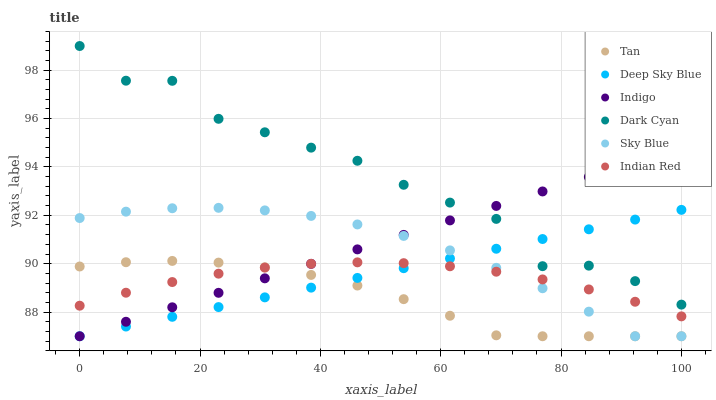Does Tan have the minimum area under the curve?
Answer yes or no. Yes. Does Dark Cyan have the maximum area under the curve?
Answer yes or no. Yes. Does Deep Sky Blue have the minimum area under the curve?
Answer yes or no. No. Does Deep Sky Blue have the maximum area under the curve?
Answer yes or no. No. Is Deep Sky Blue the smoothest?
Answer yes or no. Yes. Is Dark Cyan the roughest?
Answer yes or no. Yes. Is Indian Red the smoothest?
Answer yes or no. No. Is Indian Red the roughest?
Answer yes or no. No. Does Indigo have the lowest value?
Answer yes or no. Yes. Does Indian Red have the lowest value?
Answer yes or no. No. Does Dark Cyan have the highest value?
Answer yes or no. Yes. Does Deep Sky Blue have the highest value?
Answer yes or no. No. Is Sky Blue less than Dark Cyan?
Answer yes or no. Yes. Is Dark Cyan greater than Indian Red?
Answer yes or no. Yes. Does Indian Red intersect Indigo?
Answer yes or no. Yes. Is Indian Red less than Indigo?
Answer yes or no. No. Is Indian Red greater than Indigo?
Answer yes or no. No. Does Sky Blue intersect Dark Cyan?
Answer yes or no. No. 